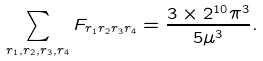Convert formula to latex. <formula><loc_0><loc_0><loc_500><loc_500>\sum _ { r _ { 1 } , r _ { 2 } , r _ { 3 } , r _ { 4 } } F _ { r _ { 1 } r _ { 2 } r _ { 3 } r _ { 4 } } = \frac { 3 \times 2 ^ { 1 0 } \pi ^ { 3 } } { 5 \mu ^ { 3 } } .</formula> 